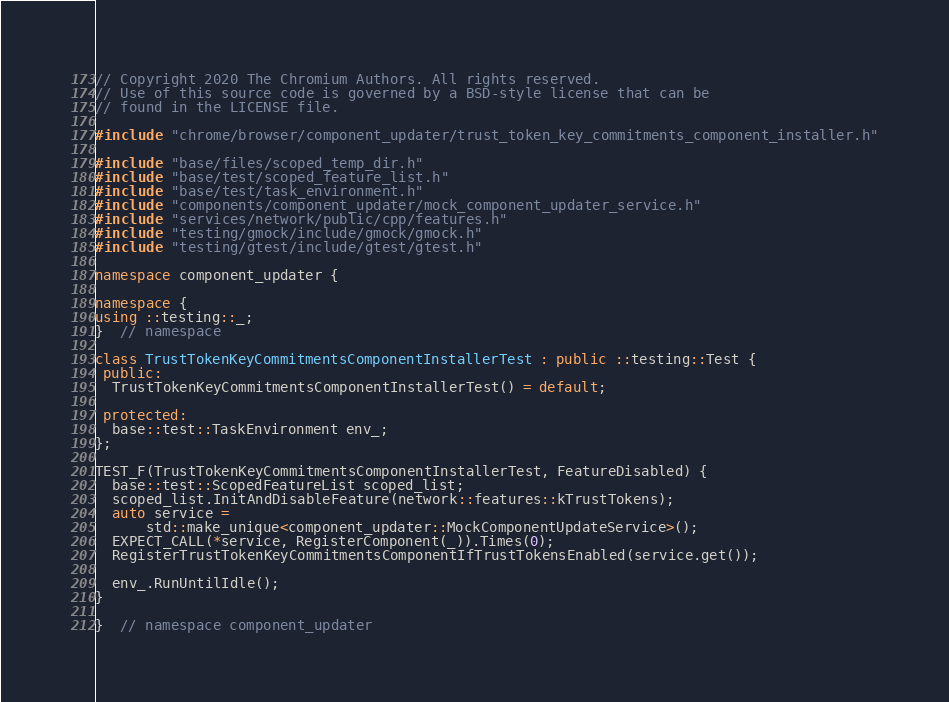Convert code to text. <code><loc_0><loc_0><loc_500><loc_500><_C++_>// Copyright 2020 The Chromium Authors. All rights reserved.
// Use of this source code is governed by a BSD-style license that can be
// found in the LICENSE file.

#include "chrome/browser/component_updater/trust_token_key_commitments_component_installer.h"

#include "base/files/scoped_temp_dir.h"
#include "base/test/scoped_feature_list.h"
#include "base/test/task_environment.h"
#include "components/component_updater/mock_component_updater_service.h"
#include "services/network/public/cpp/features.h"
#include "testing/gmock/include/gmock/gmock.h"
#include "testing/gtest/include/gtest/gtest.h"

namespace component_updater {

namespace {
using ::testing::_;
}  // namespace

class TrustTokenKeyCommitmentsComponentInstallerTest : public ::testing::Test {
 public:
  TrustTokenKeyCommitmentsComponentInstallerTest() = default;

 protected:
  base::test::TaskEnvironment env_;
};

TEST_F(TrustTokenKeyCommitmentsComponentInstallerTest, FeatureDisabled) {
  base::test::ScopedFeatureList scoped_list;
  scoped_list.InitAndDisableFeature(network::features::kTrustTokens);
  auto service =
      std::make_unique<component_updater::MockComponentUpdateService>();
  EXPECT_CALL(*service, RegisterComponent(_)).Times(0);
  RegisterTrustTokenKeyCommitmentsComponentIfTrustTokensEnabled(service.get());

  env_.RunUntilIdle();
}

}  // namespace component_updater
</code> 